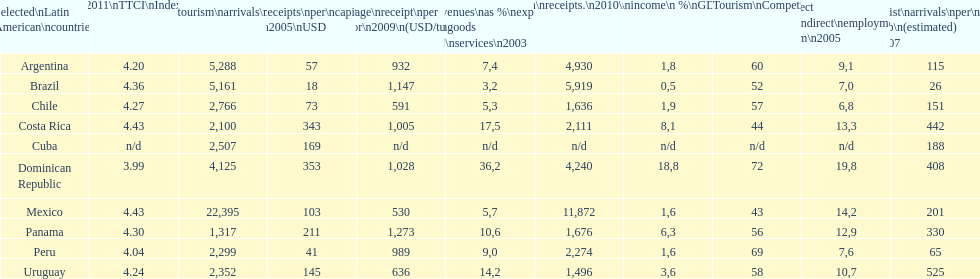How many international tourism arrivals in 2010(x1000) did mexico have? 22,395. 